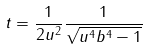Convert formula to latex. <formula><loc_0><loc_0><loc_500><loc_500>t = \frac { 1 } { 2 u ^ { 2 } } \frac { 1 } { \sqrt { u ^ { 4 } b ^ { 4 } - 1 } }</formula> 